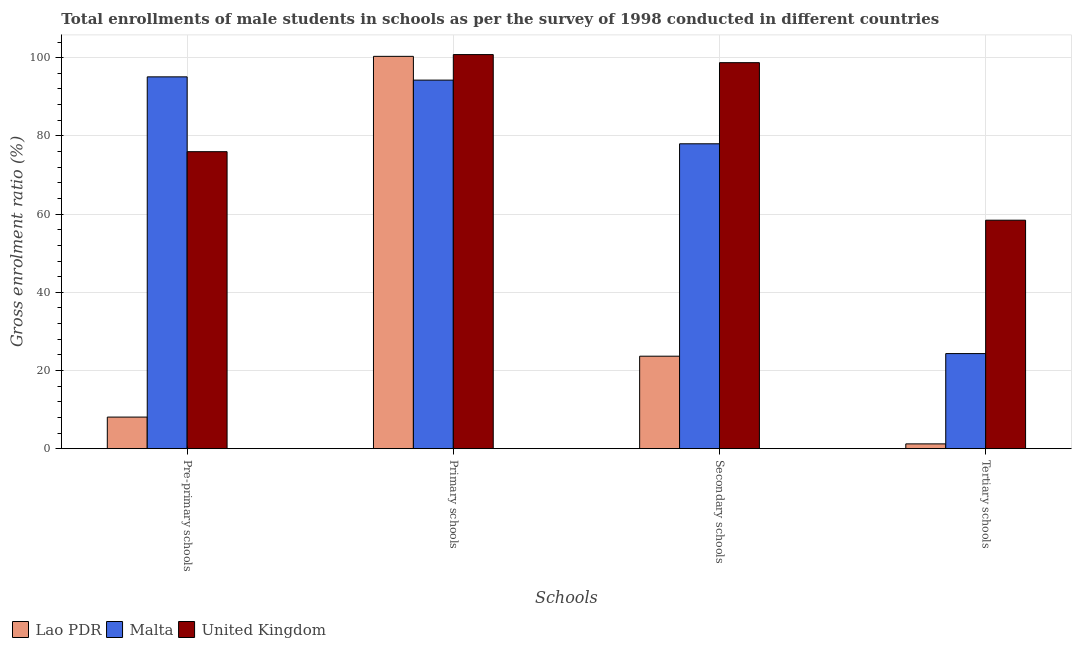How many groups of bars are there?
Offer a very short reply. 4. Are the number of bars per tick equal to the number of legend labels?
Keep it short and to the point. Yes. What is the label of the 2nd group of bars from the left?
Provide a succinct answer. Primary schools. What is the gross enrolment ratio(male) in primary schools in Lao PDR?
Ensure brevity in your answer.  100.35. Across all countries, what is the maximum gross enrolment ratio(male) in pre-primary schools?
Your response must be concise. 95.1. Across all countries, what is the minimum gross enrolment ratio(male) in tertiary schools?
Give a very brief answer. 1.23. In which country was the gross enrolment ratio(male) in primary schools minimum?
Your response must be concise. Malta. What is the total gross enrolment ratio(male) in tertiary schools in the graph?
Your answer should be very brief. 83.99. What is the difference between the gross enrolment ratio(male) in primary schools in Malta and that in United Kingdom?
Keep it short and to the point. -6.53. What is the difference between the gross enrolment ratio(male) in primary schools in Malta and the gross enrolment ratio(male) in tertiary schools in United Kingdom?
Provide a succinct answer. 35.83. What is the average gross enrolment ratio(male) in pre-primary schools per country?
Give a very brief answer. 59.72. What is the difference between the gross enrolment ratio(male) in pre-primary schools and gross enrolment ratio(male) in primary schools in United Kingdom?
Keep it short and to the point. -24.84. What is the ratio of the gross enrolment ratio(male) in pre-primary schools in Lao PDR to that in Malta?
Provide a short and direct response. 0.08. What is the difference between the highest and the second highest gross enrolment ratio(male) in tertiary schools?
Offer a terse response. 34.12. What is the difference between the highest and the lowest gross enrolment ratio(male) in secondary schools?
Offer a very short reply. 75.08. Is the sum of the gross enrolment ratio(male) in tertiary schools in United Kingdom and Lao PDR greater than the maximum gross enrolment ratio(male) in primary schools across all countries?
Give a very brief answer. No. Is it the case that in every country, the sum of the gross enrolment ratio(male) in tertiary schools and gross enrolment ratio(male) in primary schools is greater than the sum of gross enrolment ratio(male) in pre-primary schools and gross enrolment ratio(male) in secondary schools?
Offer a terse response. Yes. What does the 1st bar from the left in Primary schools represents?
Make the answer very short. Lao PDR. What does the 3rd bar from the right in Tertiary schools represents?
Provide a short and direct response. Lao PDR. Is it the case that in every country, the sum of the gross enrolment ratio(male) in pre-primary schools and gross enrolment ratio(male) in primary schools is greater than the gross enrolment ratio(male) in secondary schools?
Keep it short and to the point. Yes. How many countries are there in the graph?
Ensure brevity in your answer.  3. Does the graph contain any zero values?
Keep it short and to the point. No. How are the legend labels stacked?
Keep it short and to the point. Horizontal. What is the title of the graph?
Offer a very short reply. Total enrollments of male students in schools as per the survey of 1998 conducted in different countries. What is the label or title of the X-axis?
Offer a very short reply. Schools. What is the label or title of the Y-axis?
Make the answer very short. Gross enrolment ratio (%). What is the Gross enrolment ratio (%) in Lao PDR in Pre-primary schools?
Provide a short and direct response. 8.08. What is the Gross enrolment ratio (%) of Malta in Pre-primary schools?
Your response must be concise. 95.1. What is the Gross enrolment ratio (%) in United Kingdom in Pre-primary schools?
Provide a succinct answer. 75.97. What is the Gross enrolment ratio (%) in Lao PDR in Primary schools?
Offer a terse response. 100.35. What is the Gross enrolment ratio (%) in Malta in Primary schools?
Offer a terse response. 94.27. What is the Gross enrolment ratio (%) of United Kingdom in Primary schools?
Provide a short and direct response. 100.8. What is the Gross enrolment ratio (%) of Lao PDR in Secondary schools?
Offer a very short reply. 23.66. What is the Gross enrolment ratio (%) of Malta in Secondary schools?
Make the answer very short. 77.98. What is the Gross enrolment ratio (%) in United Kingdom in Secondary schools?
Provide a short and direct response. 98.74. What is the Gross enrolment ratio (%) of Lao PDR in Tertiary schools?
Offer a very short reply. 1.23. What is the Gross enrolment ratio (%) in Malta in Tertiary schools?
Give a very brief answer. 24.32. What is the Gross enrolment ratio (%) of United Kingdom in Tertiary schools?
Offer a very short reply. 58.44. Across all Schools, what is the maximum Gross enrolment ratio (%) in Lao PDR?
Provide a succinct answer. 100.35. Across all Schools, what is the maximum Gross enrolment ratio (%) of Malta?
Your answer should be very brief. 95.1. Across all Schools, what is the maximum Gross enrolment ratio (%) of United Kingdom?
Your answer should be compact. 100.8. Across all Schools, what is the minimum Gross enrolment ratio (%) of Lao PDR?
Your answer should be compact. 1.23. Across all Schools, what is the minimum Gross enrolment ratio (%) in Malta?
Offer a very short reply. 24.32. Across all Schools, what is the minimum Gross enrolment ratio (%) in United Kingdom?
Provide a short and direct response. 58.44. What is the total Gross enrolment ratio (%) of Lao PDR in the graph?
Offer a very short reply. 133.31. What is the total Gross enrolment ratio (%) in Malta in the graph?
Your response must be concise. 291.68. What is the total Gross enrolment ratio (%) of United Kingdom in the graph?
Your answer should be very brief. 333.95. What is the difference between the Gross enrolment ratio (%) of Lao PDR in Pre-primary schools and that in Primary schools?
Make the answer very short. -92.27. What is the difference between the Gross enrolment ratio (%) of Malta in Pre-primary schools and that in Primary schools?
Your response must be concise. 0.83. What is the difference between the Gross enrolment ratio (%) of United Kingdom in Pre-primary schools and that in Primary schools?
Offer a very short reply. -24.84. What is the difference between the Gross enrolment ratio (%) in Lao PDR in Pre-primary schools and that in Secondary schools?
Offer a terse response. -15.57. What is the difference between the Gross enrolment ratio (%) in Malta in Pre-primary schools and that in Secondary schools?
Ensure brevity in your answer.  17.12. What is the difference between the Gross enrolment ratio (%) in United Kingdom in Pre-primary schools and that in Secondary schools?
Your response must be concise. -22.77. What is the difference between the Gross enrolment ratio (%) in Lao PDR in Pre-primary schools and that in Tertiary schools?
Provide a succinct answer. 6.85. What is the difference between the Gross enrolment ratio (%) of Malta in Pre-primary schools and that in Tertiary schools?
Provide a short and direct response. 70.78. What is the difference between the Gross enrolment ratio (%) in United Kingdom in Pre-primary schools and that in Tertiary schools?
Ensure brevity in your answer.  17.53. What is the difference between the Gross enrolment ratio (%) of Lao PDR in Primary schools and that in Secondary schools?
Your response must be concise. 76.69. What is the difference between the Gross enrolment ratio (%) in Malta in Primary schools and that in Secondary schools?
Your answer should be compact. 16.29. What is the difference between the Gross enrolment ratio (%) of United Kingdom in Primary schools and that in Secondary schools?
Ensure brevity in your answer.  2.07. What is the difference between the Gross enrolment ratio (%) of Lao PDR in Primary schools and that in Tertiary schools?
Offer a very short reply. 99.12. What is the difference between the Gross enrolment ratio (%) in Malta in Primary schools and that in Tertiary schools?
Your answer should be compact. 69.95. What is the difference between the Gross enrolment ratio (%) of United Kingdom in Primary schools and that in Tertiary schools?
Ensure brevity in your answer.  42.36. What is the difference between the Gross enrolment ratio (%) of Lao PDR in Secondary schools and that in Tertiary schools?
Ensure brevity in your answer.  22.43. What is the difference between the Gross enrolment ratio (%) in Malta in Secondary schools and that in Tertiary schools?
Provide a short and direct response. 53.66. What is the difference between the Gross enrolment ratio (%) in United Kingdom in Secondary schools and that in Tertiary schools?
Provide a short and direct response. 40.29. What is the difference between the Gross enrolment ratio (%) of Lao PDR in Pre-primary schools and the Gross enrolment ratio (%) of Malta in Primary schools?
Offer a very short reply. -86.19. What is the difference between the Gross enrolment ratio (%) of Lao PDR in Pre-primary schools and the Gross enrolment ratio (%) of United Kingdom in Primary schools?
Keep it short and to the point. -92.72. What is the difference between the Gross enrolment ratio (%) of Malta in Pre-primary schools and the Gross enrolment ratio (%) of United Kingdom in Primary schools?
Ensure brevity in your answer.  -5.7. What is the difference between the Gross enrolment ratio (%) of Lao PDR in Pre-primary schools and the Gross enrolment ratio (%) of Malta in Secondary schools?
Your answer should be compact. -69.9. What is the difference between the Gross enrolment ratio (%) in Lao PDR in Pre-primary schools and the Gross enrolment ratio (%) in United Kingdom in Secondary schools?
Your response must be concise. -90.66. What is the difference between the Gross enrolment ratio (%) in Malta in Pre-primary schools and the Gross enrolment ratio (%) in United Kingdom in Secondary schools?
Your response must be concise. -3.63. What is the difference between the Gross enrolment ratio (%) of Lao PDR in Pre-primary schools and the Gross enrolment ratio (%) of Malta in Tertiary schools?
Keep it short and to the point. -16.24. What is the difference between the Gross enrolment ratio (%) of Lao PDR in Pre-primary schools and the Gross enrolment ratio (%) of United Kingdom in Tertiary schools?
Offer a terse response. -50.36. What is the difference between the Gross enrolment ratio (%) of Malta in Pre-primary schools and the Gross enrolment ratio (%) of United Kingdom in Tertiary schools?
Your answer should be very brief. 36.66. What is the difference between the Gross enrolment ratio (%) of Lao PDR in Primary schools and the Gross enrolment ratio (%) of Malta in Secondary schools?
Offer a very short reply. 22.36. What is the difference between the Gross enrolment ratio (%) in Lao PDR in Primary schools and the Gross enrolment ratio (%) in United Kingdom in Secondary schools?
Give a very brief answer. 1.61. What is the difference between the Gross enrolment ratio (%) in Malta in Primary schools and the Gross enrolment ratio (%) in United Kingdom in Secondary schools?
Your response must be concise. -4.47. What is the difference between the Gross enrolment ratio (%) in Lao PDR in Primary schools and the Gross enrolment ratio (%) in Malta in Tertiary schools?
Your response must be concise. 76.02. What is the difference between the Gross enrolment ratio (%) in Lao PDR in Primary schools and the Gross enrolment ratio (%) in United Kingdom in Tertiary schools?
Offer a very short reply. 41.91. What is the difference between the Gross enrolment ratio (%) of Malta in Primary schools and the Gross enrolment ratio (%) of United Kingdom in Tertiary schools?
Provide a short and direct response. 35.83. What is the difference between the Gross enrolment ratio (%) of Lao PDR in Secondary schools and the Gross enrolment ratio (%) of Malta in Tertiary schools?
Provide a short and direct response. -0.67. What is the difference between the Gross enrolment ratio (%) in Lao PDR in Secondary schools and the Gross enrolment ratio (%) in United Kingdom in Tertiary schools?
Make the answer very short. -34.79. What is the difference between the Gross enrolment ratio (%) of Malta in Secondary schools and the Gross enrolment ratio (%) of United Kingdom in Tertiary schools?
Offer a terse response. 19.54. What is the average Gross enrolment ratio (%) in Lao PDR per Schools?
Your answer should be very brief. 33.33. What is the average Gross enrolment ratio (%) in Malta per Schools?
Make the answer very short. 72.92. What is the average Gross enrolment ratio (%) of United Kingdom per Schools?
Your response must be concise. 83.49. What is the difference between the Gross enrolment ratio (%) of Lao PDR and Gross enrolment ratio (%) of Malta in Pre-primary schools?
Provide a short and direct response. -87.02. What is the difference between the Gross enrolment ratio (%) of Lao PDR and Gross enrolment ratio (%) of United Kingdom in Pre-primary schools?
Keep it short and to the point. -67.89. What is the difference between the Gross enrolment ratio (%) of Malta and Gross enrolment ratio (%) of United Kingdom in Pre-primary schools?
Provide a short and direct response. 19.14. What is the difference between the Gross enrolment ratio (%) of Lao PDR and Gross enrolment ratio (%) of Malta in Primary schools?
Offer a very short reply. 6.08. What is the difference between the Gross enrolment ratio (%) of Lao PDR and Gross enrolment ratio (%) of United Kingdom in Primary schools?
Ensure brevity in your answer.  -0.46. What is the difference between the Gross enrolment ratio (%) of Malta and Gross enrolment ratio (%) of United Kingdom in Primary schools?
Your answer should be compact. -6.53. What is the difference between the Gross enrolment ratio (%) of Lao PDR and Gross enrolment ratio (%) of Malta in Secondary schools?
Your answer should be compact. -54.33. What is the difference between the Gross enrolment ratio (%) in Lao PDR and Gross enrolment ratio (%) in United Kingdom in Secondary schools?
Your response must be concise. -75.08. What is the difference between the Gross enrolment ratio (%) in Malta and Gross enrolment ratio (%) in United Kingdom in Secondary schools?
Your answer should be very brief. -20.75. What is the difference between the Gross enrolment ratio (%) in Lao PDR and Gross enrolment ratio (%) in Malta in Tertiary schools?
Offer a terse response. -23.1. What is the difference between the Gross enrolment ratio (%) in Lao PDR and Gross enrolment ratio (%) in United Kingdom in Tertiary schools?
Your answer should be very brief. -57.21. What is the difference between the Gross enrolment ratio (%) of Malta and Gross enrolment ratio (%) of United Kingdom in Tertiary schools?
Offer a very short reply. -34.12. What is the ratio of the Gross enrolment ratio (%) in Lao PDR in Pre-primary schools to that in Primary schools?
Your response must be concise. 0.08. What is the ratio of the Gross enrolment ratio (%) of Malta in Pre-primary schools to that in Primary schools?
Keep it short and to the point. 1.01. What is the ratio of the Gross enrolment ratio (%) in United Kingdom in Pre-primary schools to that in Primary schools?
Offer a terse response. 0.75. What is the ratio of the Gross enrolment ratio (%) in Lao PDR in Pre-primary schools to that in Secondary schools?
Offer a terse response. 0.34. What is the ratio of the Gross enrolment ratio (%) in Malta in Pre-primary schools to that in Secondary schools?
Give a very brief answer. 1.22. What is the ratio of the Gross enrolment ratio (%) of United Kingdom in Pre-primary schools to that in Secondary schools?
Provide a succinct answer. 0.77. What is the ratio of the Gross enrolment ratio (%) of Lao PDR in Pre-primary schools to that in Tertiary schools?
Ensure brevity in your answer.  6.58. What is the ratio of the Gross enrolment ratio (%) of Malta in Pre-primary schools to that in Tertiary schools?
Provide a short and direct response. 3.91. What is the ratio of the Gross enrolment ratio (%) of United Kingdom in Pre-primary schools to that in Tertiary schools?
Offer a very short reply. 1.3. What is the ratio of the Gross enrolment ratio (%) of Lao PDR in Primary schools to that in Secondary schools?
Your answer should be very brief. 4.24. What is the ratio of the Gross enrolment ratio (%) in Malta in Primary schools to that in Secondary schools?
Your response must be concise. 1.21. What is the ratio of the Gross enrolment ratio (%) in United Kingdom in Primary schools to that in Secondary schools?
Provide a succinct answer. 1.02. What is the ratio of the Gross enrolment ratio (%) in Lao PDR in Primary schools to that in Tertiary schools?
Provide a succinct answer. 81.72. What is the ratio of the Gross enrolment ratio (%) in Malta in Primary schools to that in Tertiary schools?
Provide a short and direct response. 3.88. What is the ratio of the Gross enrolment ratio (%) of United Kingdom in Primary schools to that in Tertiary schools?
Your answer should be compact. 1.72. What is the ratio of the Gross enrolment ratio (%) of Lao PDR in Secondary schools to that in Tertiary schools?
Ensure brevity in your answer.  19.27. What is the ratio of the Gross enrolment ratio (%) of Malta in Secondary schools to that in Tertiary schools?
Your response must be concise. 3.21. What is the ratio of the Gross enrolment ratio (%) in United Kingdom in Secondary schools to that in Tertiary schools?
Offer a terse response. 1.69. What is the difference between the highest and the second highest Gross enrolment ratio (%) of Lao PDR?
Ensure brevity in your answer.  76.69. What is the difference between the highest and the second highest Gross enrolment ratio (%) of Malta?
Your answer should be very brief. 0.83. What is the difference between the highest and the second highest Gross enrolment ratio (%) of United Kingdom?
Make the answer very short. 2.07. What is the difference between the highest and the lowest Gross enrolment ratio (%) in Lao PDR?
Provide a succinct answer. 99.12. What is the difference between the highest and the lowest Gross enrolment ratio (%) of Malta?
Your answer should be compact. 70.78. What is the difference between the highest and the lowest Gross enrolment ratio (%) in United Kingdom?
Your response must be concise. 42.36. 